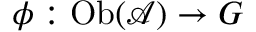<formula> <loc_0><loc_0><loc_500><loc_500>\phi \colon O b ( { \mathcal { A } } ) \to G</formula> 